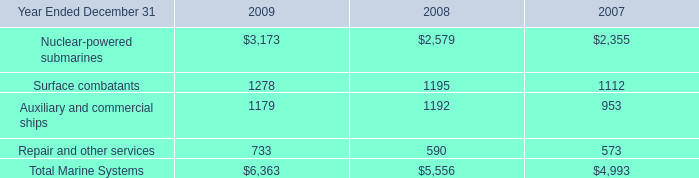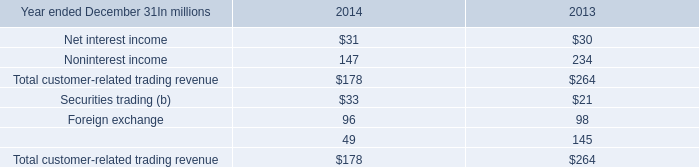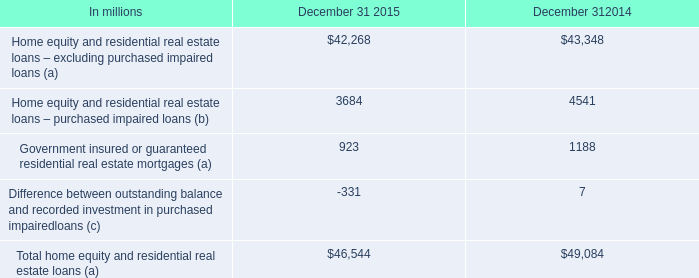between 2014 and 2013 , average 95% ( 95 % ) var decreased by how much in millions?\\n\\n 
Computations: (3.5 - 2.1)
Answer: 1.4. 